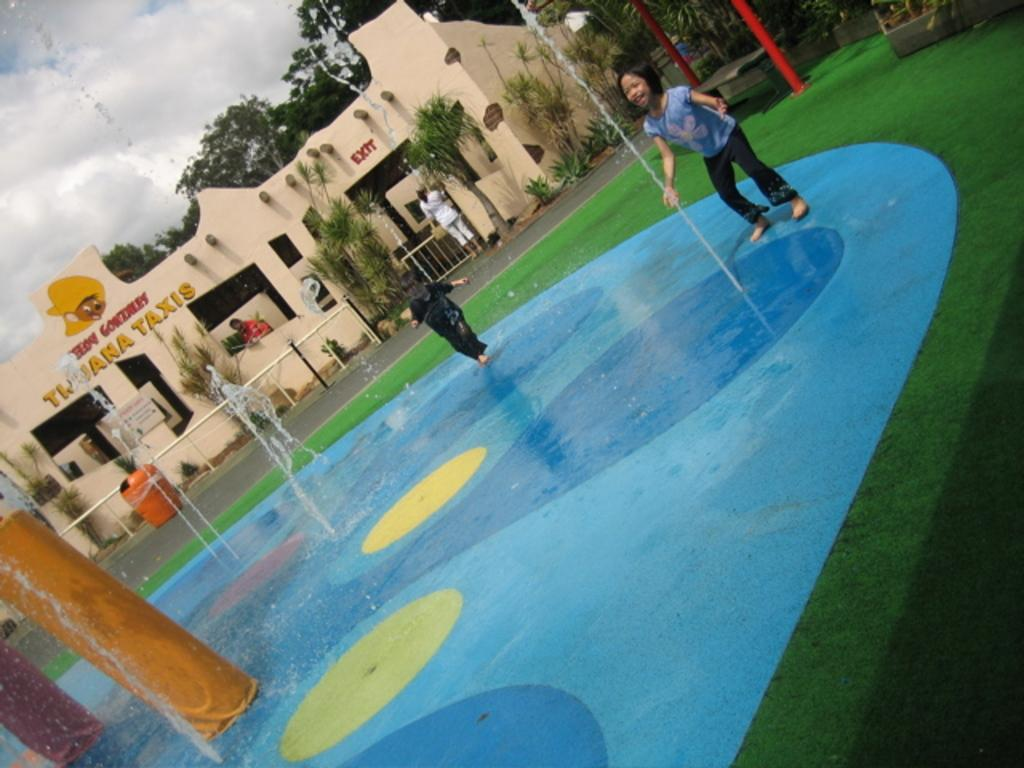What can be seen on the floor in the image? There are children standing on the floor in the image. What type of structures are present in the image? There are fountains, bins, barrier poles, and a building in the image. What is the person in the image doing? There is a person standing on the road in the image. What type of vegetation is visible in the image? There are trees and plants in the image. What is visible in the background of the image? There is a building, trees, plants, and the sky in the image. What can be seen in the sky? The sky is visible in the image, and there are clouds in the sky. What grade did the children receive for their science project in the image? There is no information about a science project or grades in the image. Can you hear the person on the road laughing in the image? There is no sound or indication of laughter in the image. 